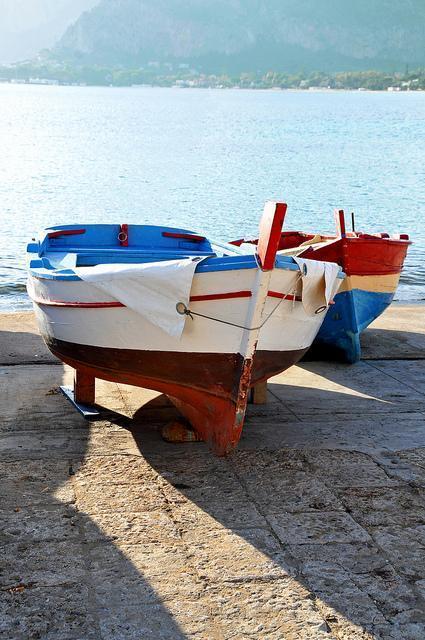How many boats are pictured?
Give a very brief answer. 2. How many boats are in the photo?
Give a very brief answer. 2. 